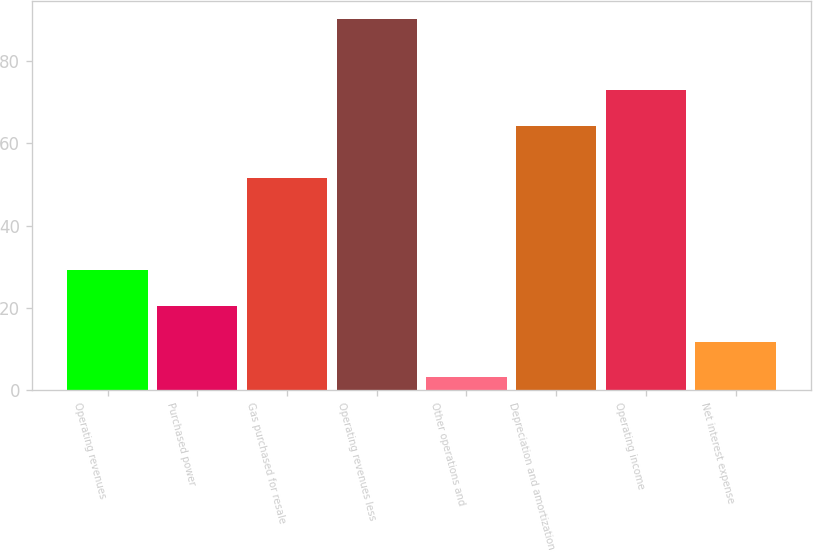Convert chart to OTSL. <chart><loc_0><loc_0><loc_500><loc_500><bar_chart><fcel>Operating revenues<fcel>Purchased power<fcel>Gas purchased for resale<fcel>Operating revenues less<fcel>Other operations and<fcel>Depreciation and amortization<fcel>Operating income<fcel>Net interest expense<nl><fcel>29.23<fcel>20.52<fcel>51.7<fcel>90.2<fcel>3.1<fcel>64.3<fcel>73.01<fcel>11.81<nl></chart> 